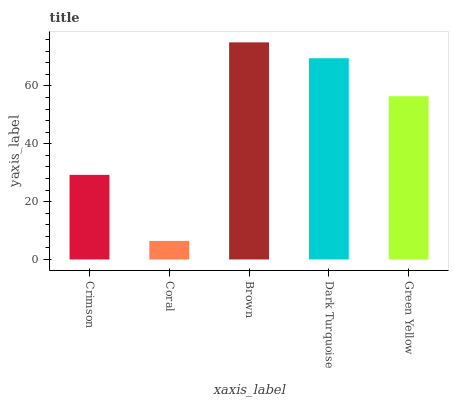Is Coral the minimum?
Answer yes or no. Yes. Is Brown the maximum?
Answer yes or no. Yes. Is Brown the minimum?
Answer yes or no. No. Is Coral the maximum?
Answer yes or no. No. Is Brown greater than Coral?
Answer yes or no. Yes. Is Coral less than Brown?
Answer yes or no. Yes. Is Coral greater than Brown?
Answer yes or no. No. Is Brown less than Coral?
Answer yes or no. No. Is Green Yellow the high median?
Answer yes or no. Yes. Is Green Yellow the low median?
Answer yes or no. Yes. Is Coral the high median?
Answer yes or no. No. Is Crimson the low median?
Answer yes or no. No. 